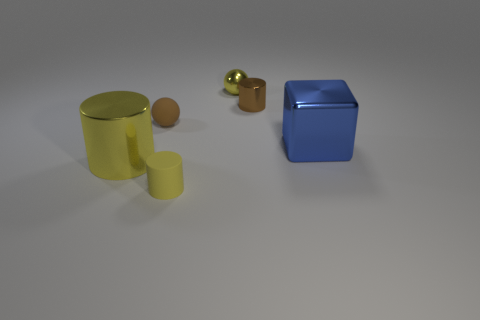Subtract all tiny yellow cylinders. How many cylinders are left? 2 Add 4 cylinders. How many objects exist? 10 Subtract 2 cylinders. How many cylinders are left? 1 Subtract all large brown rubber balls. Subtract all small metal spheres. How many objects are left? 5 Add 3 big blue metallic objects. How many big blue metallic objects are left? 4 Add 4 blue shiny things. How many blue shiny things exist? 5 Subtract all brown spheres. How many spheres are left? 1 Subtract 0 red blocks. How many objects are left? 6 Subtract all cubes. How many objects are left? 5 Subtract all brown spheres. Subtract all brown cylinders. How many spheres are left? 1 